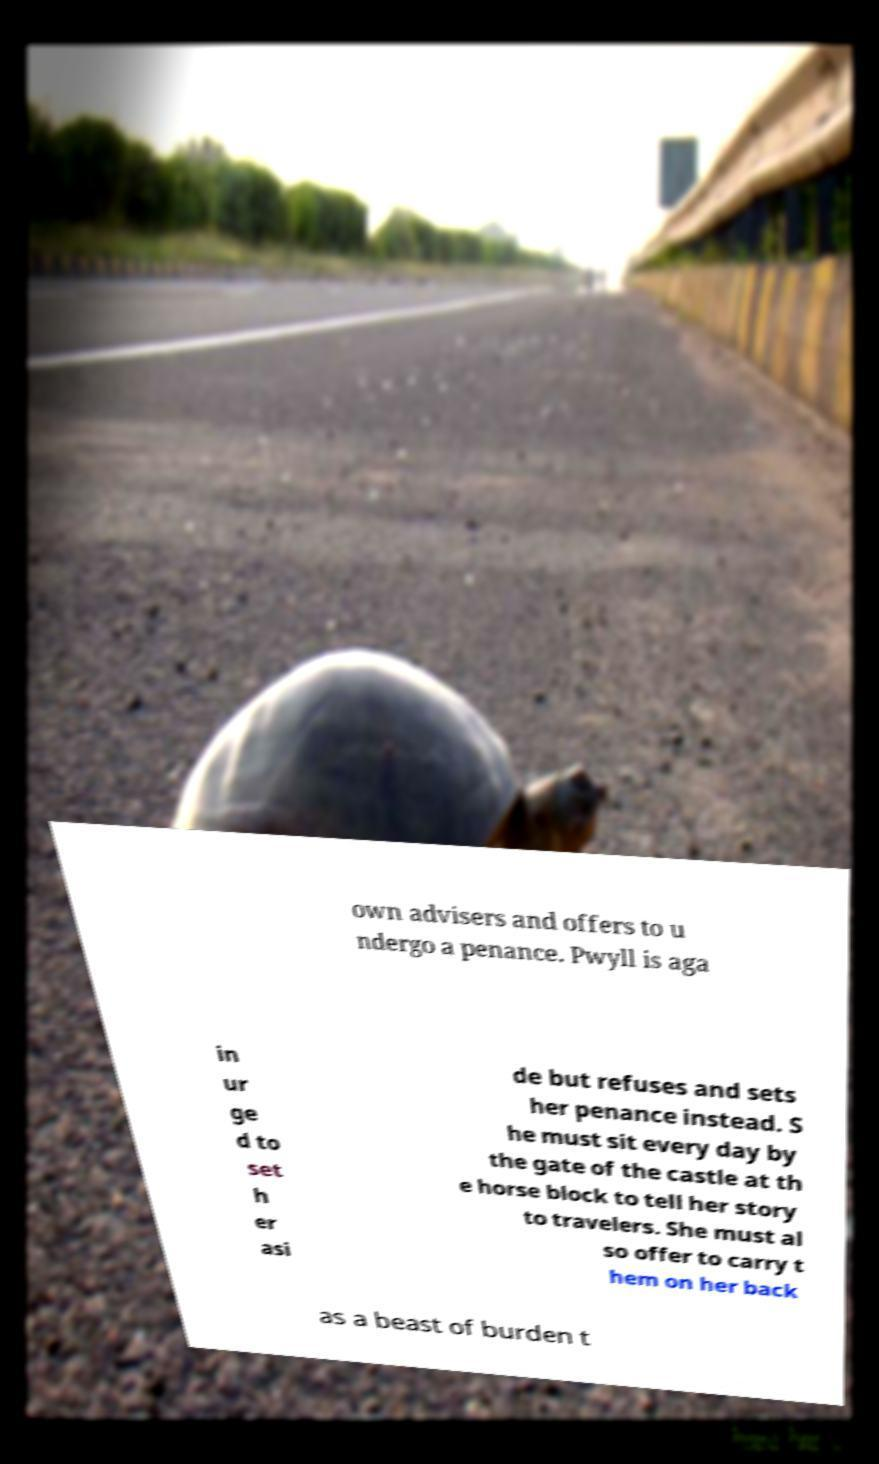Can you read and provide the text displayed in the image?This photo seems to have some interesting text. Can you extract and type it out for me? own advisers and offers to u ndergo a penance. Pwyll is aga in ur ge d to set h er asi de but refuses and sets her penance instead. S he must sit every day by the gate of the castle at th e horse block to tell her story to travelers. She must al so offer to carry t hem on her back as a beast of burden t 